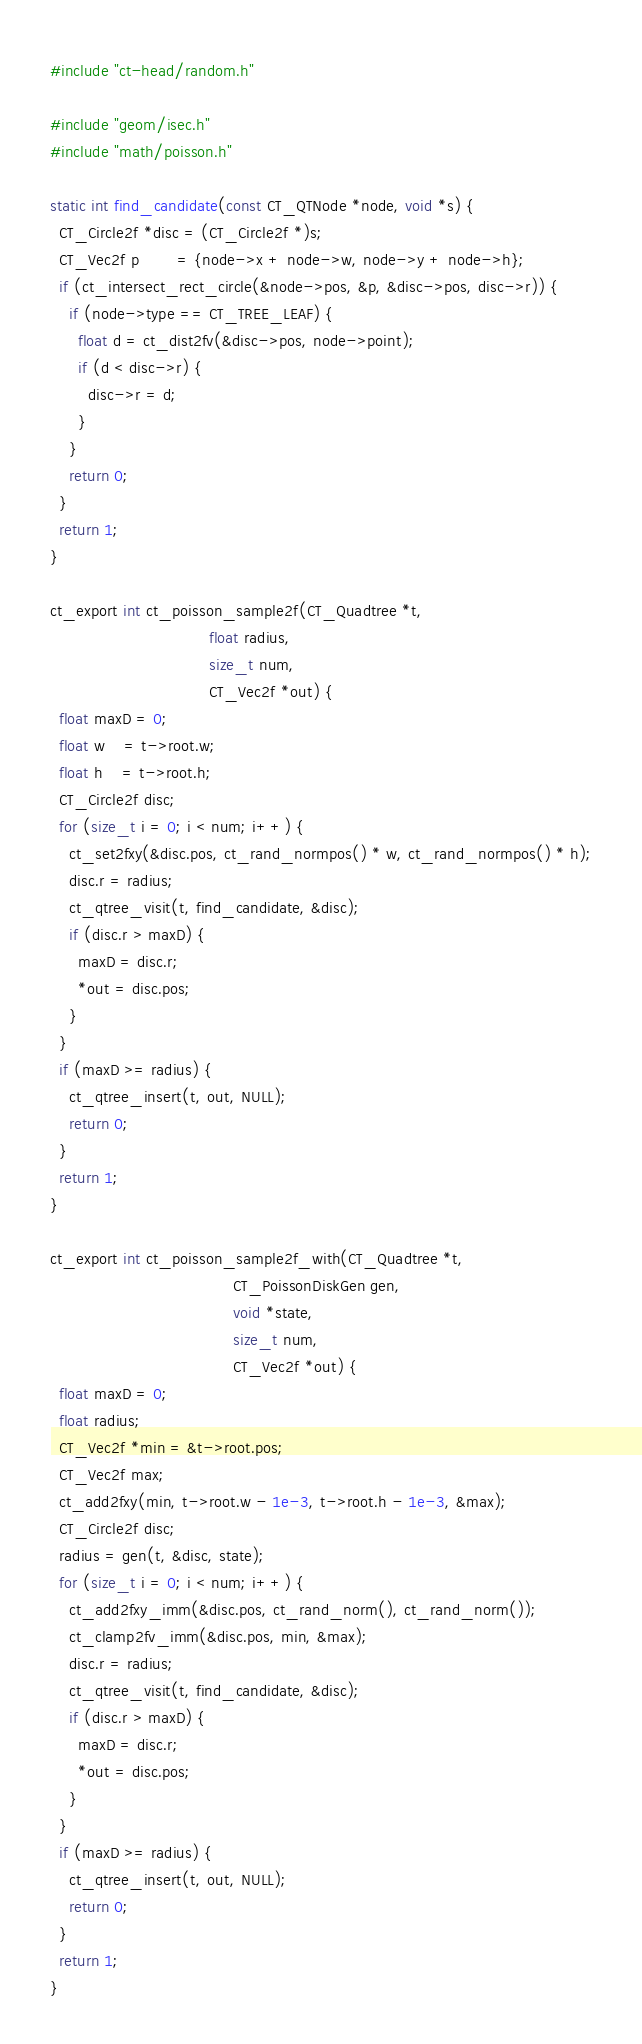<code> <loc_0><loc_0><loc_500><loc_500><_C_>
#include "ct-head/random.h"

#include "geom/isec.h"
#include "math/poisson.h"

static int find_candidate(const CT_QTNode *node, void *s) {
  CT_Circle2f *disc = (CT_Circle2f *)s;
  CT_Vec2f p        = {node->x + node->w, node->y + node->h};
  if (ct_intersect_rect_circle(&node->pos, &p, &disc->pos, disc->r)) {
    if (node->type == CT_TREE_LEAF) {
      float d = ct_dist2fv(&disc->pos, node->point);
      if (d < disc->r) {
        disc->r = d;
      }
    }
    return 0;
  }
  return 1;
}

ct_export int ct_poisson_sample2f(CT_Quadtree *t,
                                  float radius,
                                  size_t num,
                                  CT_Vec2f *out) {
  float maxD = 0;
  float w    = t->root.w;
  float h    = t->root.h;
  CT_Circle2f disc;
  for (size_t i = 0; i < num; i++) {
    ct_set2fxy(&disc.pos, ct_rand_normpos() * w, ct_rand_normpos() * h);
    disc.r = radius;
    ct_qtree_visit(t, find_candidate, &disc);
    if (disc.r > maxD) {
      maxD = disc.r;
      *out = disc.pos;
    }
  }
  if (maxD >= radius) {
    ct_qtree_insert(t, out, NULL);
    return 0;
  }
  return 1;
}

ct_export int ct_poisson_sample2f_with(CT_Quadtree *t,
                                       CT_PoissonDiskGen gen,
                                       void *state,
                                       size_t num,
                                       CT_Vec2f *out) {
  float maxD = 0;
  float radius;
  CT_Vec2f *min = &t->root.pos;
  CT_Vec2f max;
  ct_add2fxy(min, t->root.w - 1e-3, t->root.h - 1e-3, &max);
  CT_Circle2f disc;
  radius = gen(t, &disc, state);
  for (size_t i = 0; i < num; i++) {
    ct_add2fxy_imm(&disc.pos, ct_rand_norm(), ct_rand_norm());
    ct_clamp2fv_imm(&disc.pos, min, &max);
    disc.r = radius;
    ct_qtree_visit(t, find_candidate, &disc);
    if (disc.r > maxD) {
      maxD = disc.r;
      *out = disc.pos;
    }
  }
  if (maxD >= radius) {
    ct_qtree_insert(t, out, NULL);
    return 0;
  }
  return 1;
}
</code> 